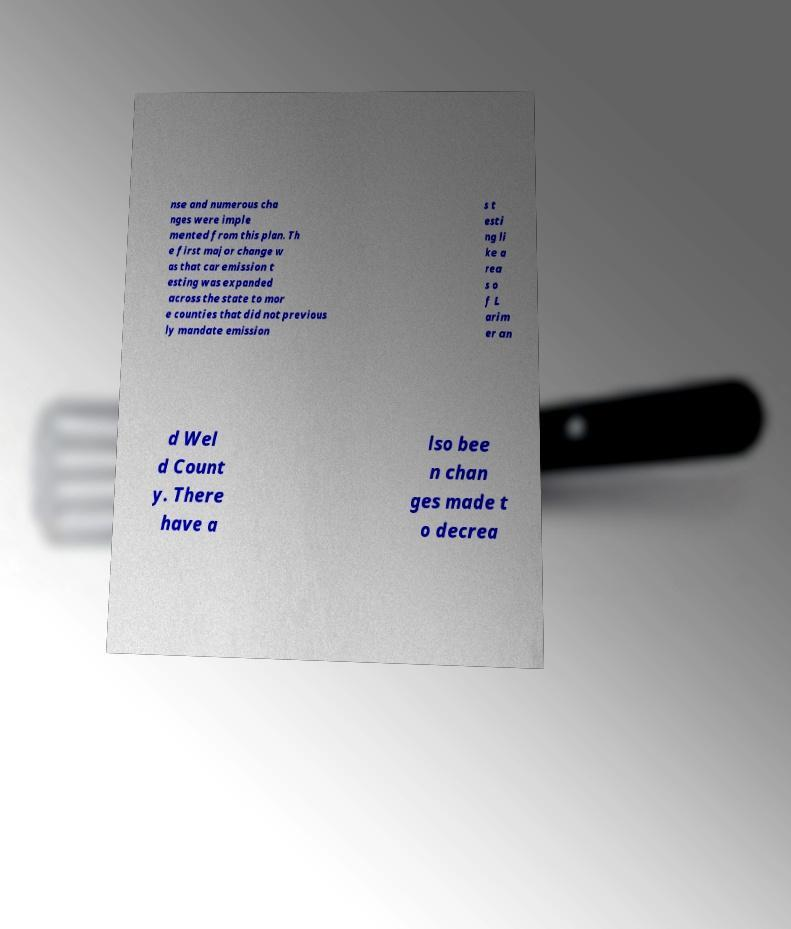I need the written content from this picture converted into text. Can you do that? nse and numerous cha nges were imple mented from this plan. Th e first major change w as that car emission t esting was expanded across the state to mor e counties that did not previous ly mandate emission s t esti ng li ke a rea s o f L arim er an d Wel d Count y. There have a lso bee n chan ges made t o decrea 